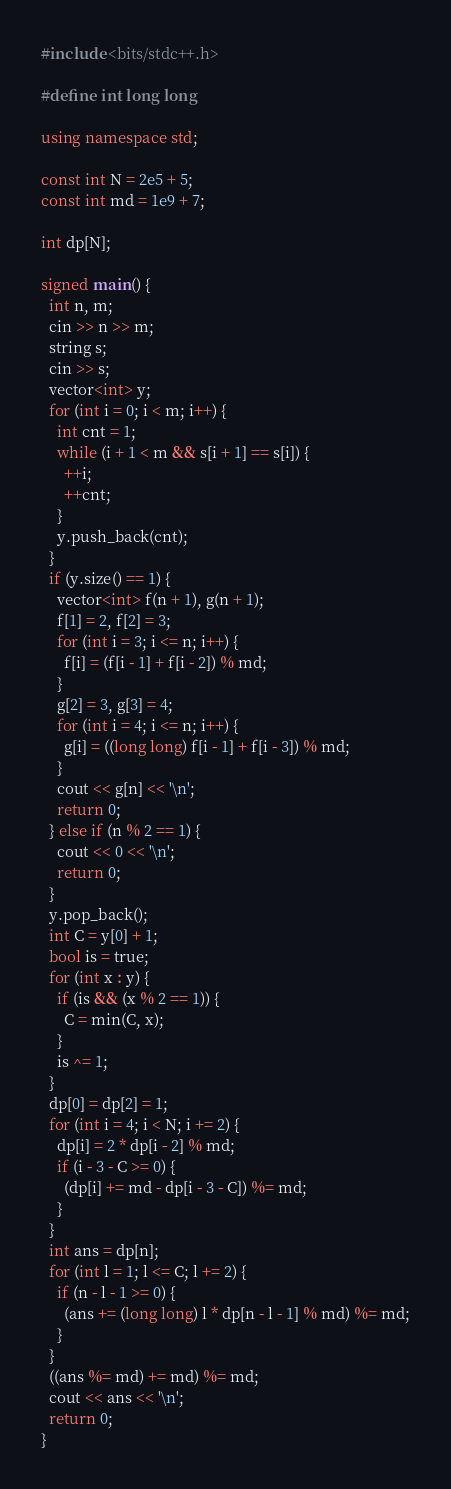<code> <loc_0><loc_0><loc_500><loc_500><_C++_>#include <bits/stdc++.h>

#define int long long

using namespace std;

const int N = 2e5 + 5;
const int md = 1e9 + 7;

int dp[N];

signed main() {
  int n, m;
  cin >> n >> m;
  string s;
  cin >> s;
  vector<int> y;
  for (int i = 0; i < m; i++) {
    int cnt = 1;
    while (i + 1 < m && s[i + 1] == s[i]) {
      ++i;
      ++cnt;
    }
    y.push_back(cnt);
  }
  if (y.size() == 1) {
    vector<int> f(n + 1), g(n + 1);
    f[1] = 2, f[2] = 3;
    for (int i = 3; i <= n; i++) {
      f[i] = (f[i - 1] + f[i - 2]) % md;
    }
    g[2] = 3, g[3] = 4;
    for (int i = 4; i <= n; i++) {
      g[i] = ((long long) f[i - 1] + f[i - 3]) % md;
    }
    cout << g[n] << '\n';
    return 0;
  } else if (n % 2 == 1) {
    cout << 0 << '\n';
    return 0;
  }
  y.pop_back();
  int C = y[0] + 1;
  bool is = true;
  for (int x : y) {
    if (is && (x % 2 == 1)) {
      C = min(C, x);
    }
    is ^= 1;
  }
  dp[0] = dp[2] = 1;
  for (int i = 4; i < N; i += 2) {
    dp[i] = 2 * dp[i - 2] % md;
    if (i - 3 - C >= 0) {
      (dp[i] += md - dp[i - 3 - C]) %= md;
    }
  }
  int ans = dp[n];
  for (int l = 1; l <= C; l += 2) {
    if (n - l - 1 >= 0) {
      (ans += (long long) l * dp[n - l - 1] % md) %= md;
    }
  }
  ((ans %= md) += md) %= md;
  cout << ans << '\n';
  return 0;
}
</code> 